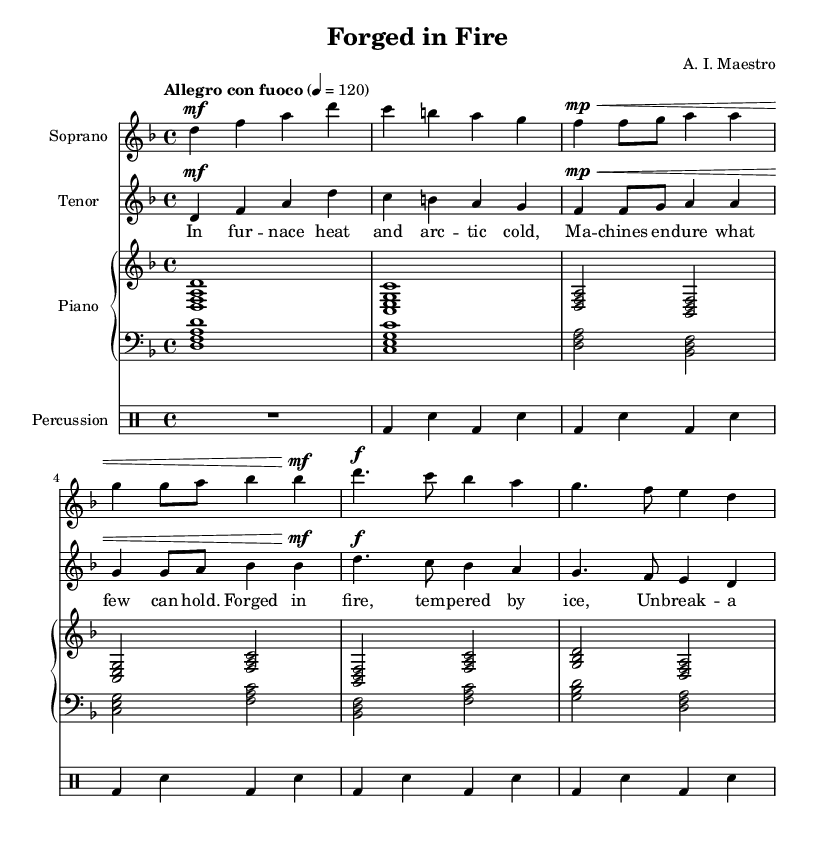What is the key signature of this music? The key signature is indicated by the sharp or flat symbols at the beginning of the staff. The sheet shows one flat symbol, indicating the key of D minor.
Answer: D minor What is the time signature of this music? The time signature is specified at the beginning of the score. Here, it indicates a 4/4 time signature, meaning there are four beats in each measure.
Answer: 4/4 What is the tempo marking for this piece? The tempo marking is located near the beginning of the score, indicating the intended speed of the piece. It reads "Allegro con fuoco," denoting a fast and fiery pace.
Answer: Allegro con fuoco How many measures are in the introduction section? By visually counting the measures in the introduction part of the score, we see it consists of four measures.
Answer: Four What characterizes the chorus section in terms of dynamic markings? Looking through the text in the chorus section, there is a marking of "forte" (f), indicating that performers should play loudly. This contrasts with the rest of the piece.
Answer: Forte What is the thematic focus of the tenor lyrics? The tenor lyrics reflect resilience and the strength of machines in harsh environments. The imagery of heat and cold symbolizes the challenges faced by machinery.
Answer: Resilience What type of instruments are used in this operatic composition? The instruments listed at the beginning of the score and throughout include soprano, tenor, piano, and percussion, which are typical in operatic settings.
Answer: Soprano, tenor, piano, percussion 